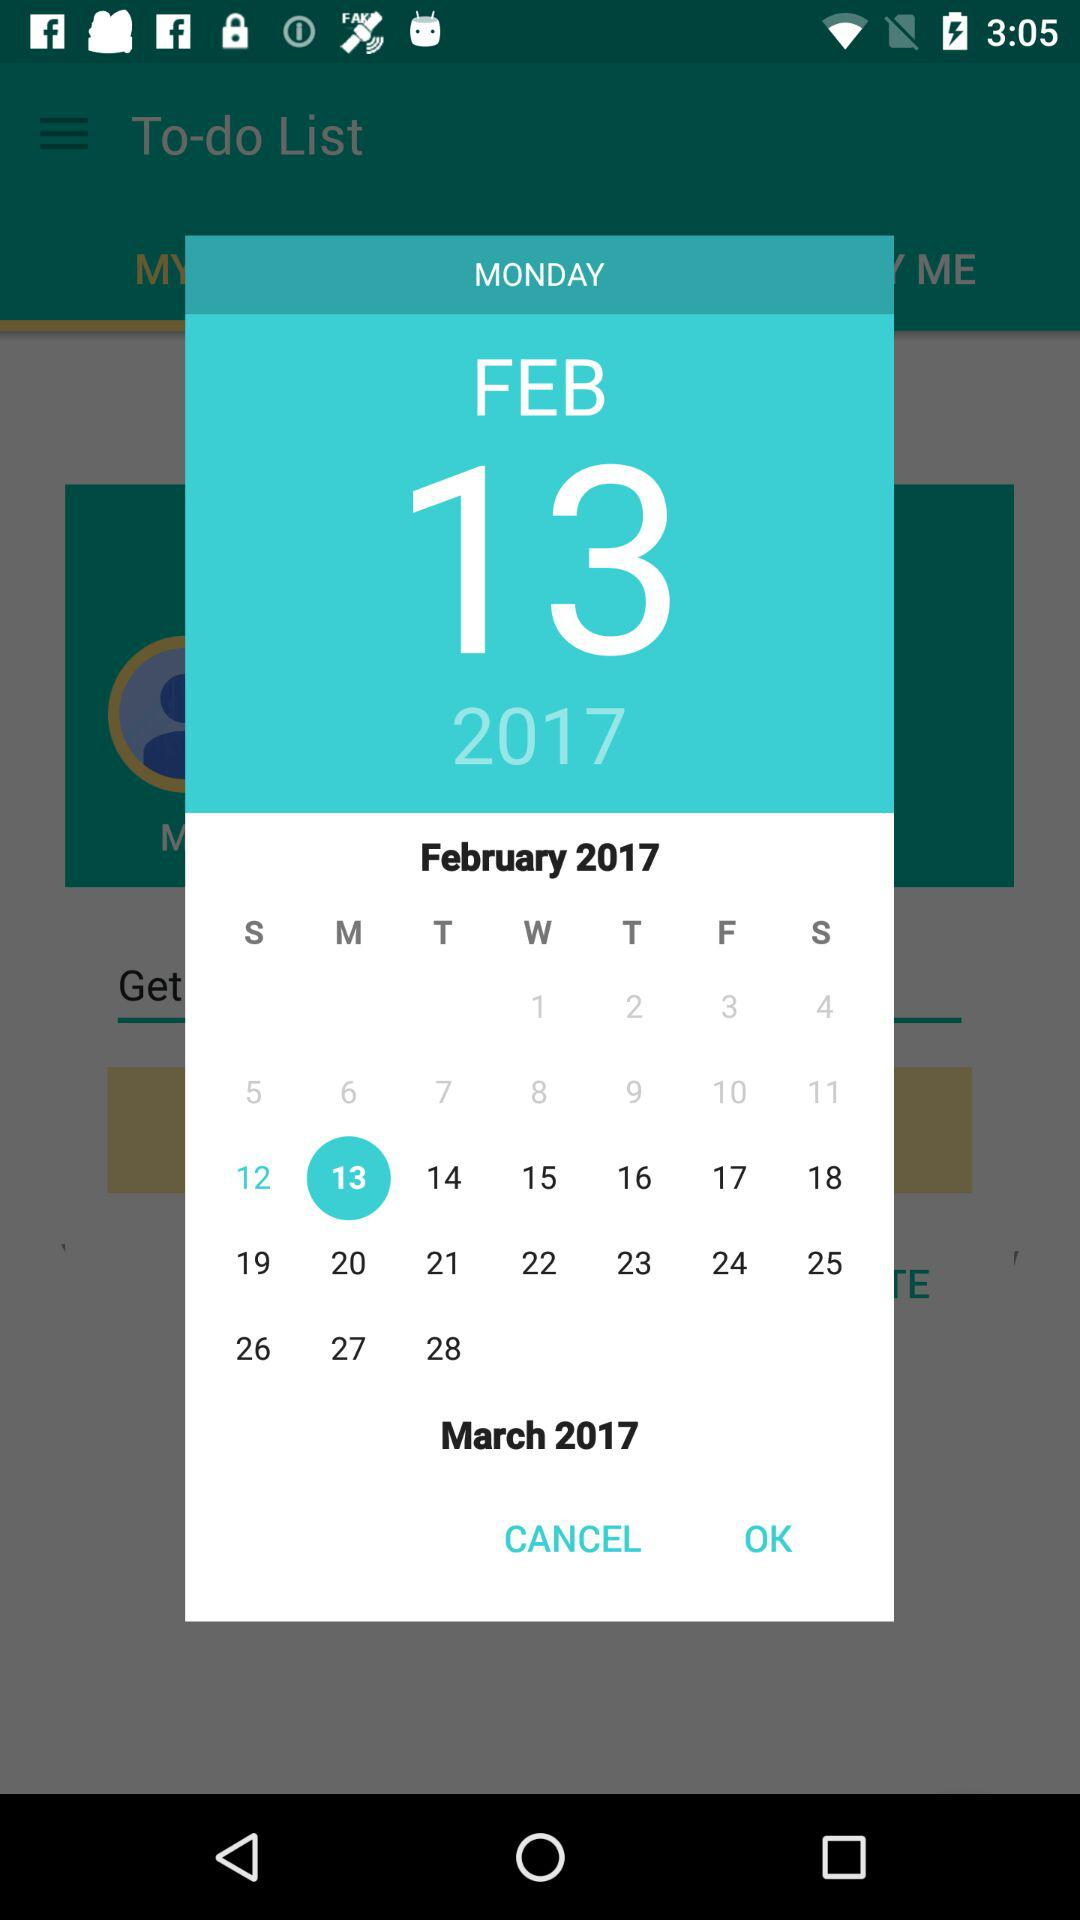What day is February 13, 2017? The day is Monday. 